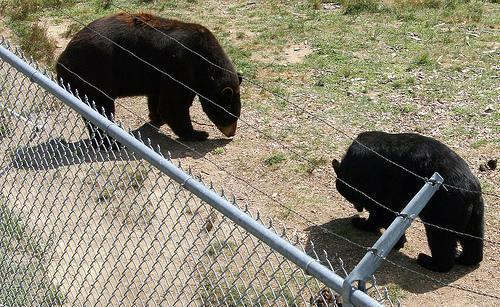How many bears are there?
Give a very brief answer. 2. 